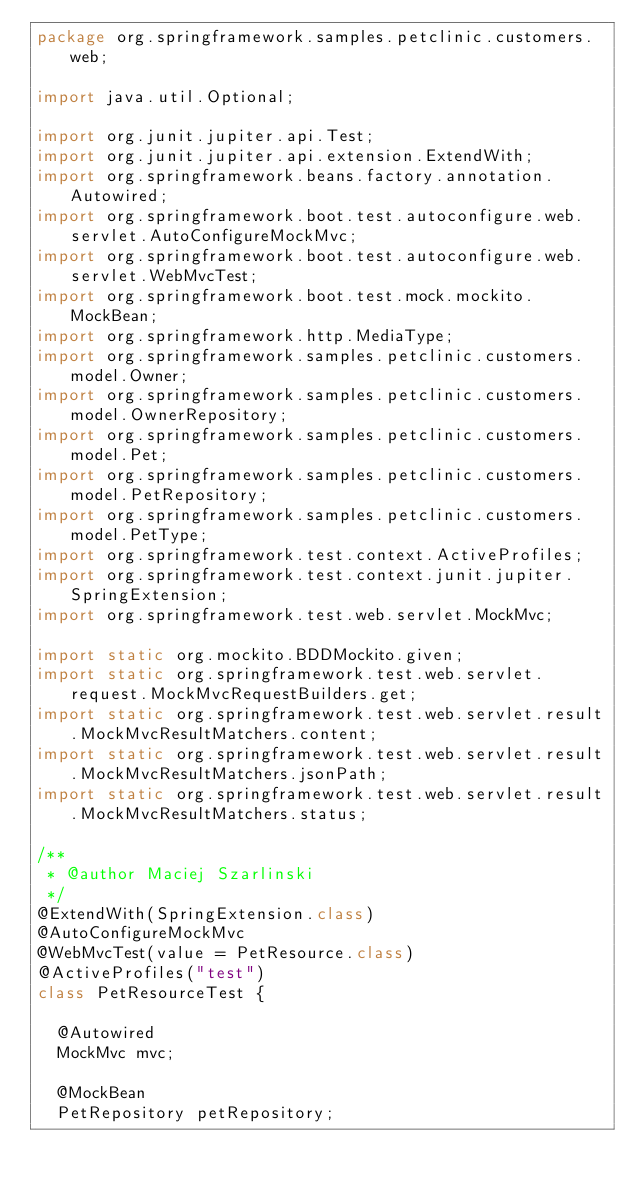Convert code to text. <code><loc_0><loc_0><loc_500><loc_500><_Java_>package org.springframework.samples.petclinic.customers.web;

import java.util.Optional;

import org.junit.jupiter.api.Test;
import org.junit.jupiter.api.extension.ExtendWith;
import org.springframework.beans.factory.annotation.Autowired;
import org.springframework.boot.test.autoconfigure.web.servlet.AutoConfigureMockMvc;
import org.springframework.boot.test.autoconfigure.web.servlet.WebMvcTest;
import org.springframework.boot.test.mock.mockito.MockBean;
import org.springframework.http.MediaType;
import org.springframework.samples.petclinic.customers.model.Owner;
import org.springframework.samples.petclinic.customers.model.OwnerRepository;
import org.springframework.samples.petclinic.customers.model.Pet;
import org.springframework.samples.petclinic.customers.model.PetRepository;
import org.springframework.samples.petclinic.customers.model.PetType;
import org.springframework.test.context.ActiveProfiles;
import org.springframework.test.context.junit.jupiter.SpringExtension;
import org.springframework.test.web.servlet.MockMvc;

import static org.mockito.BDDMockito.given;
import static org.springframework.test.web.servlet.request.MockMvcRequestBuilders.get;
import static org.springframework.test.web.servlet.result.MockMvcResultMatchers.content;
import static org.springframework.test.web.servlet.result.MockMvcResultMatchers.jsonPath;
import static org.springframework.test.web.servlet.result.MockMvcResultMatchers.status;

/**
 * @author Maciej Szarlinski
 */
@ExtendWith(SpringExtension.class)
@AutoConfigureMockMvc
@WebMvcTest(value = PetResource.class)
@ActiveProfiles("test")
class PetResourceTest {

	@Autowired
	MockMvc mvc;

	@MockBean
	PetRepository petRepository;
</code> 